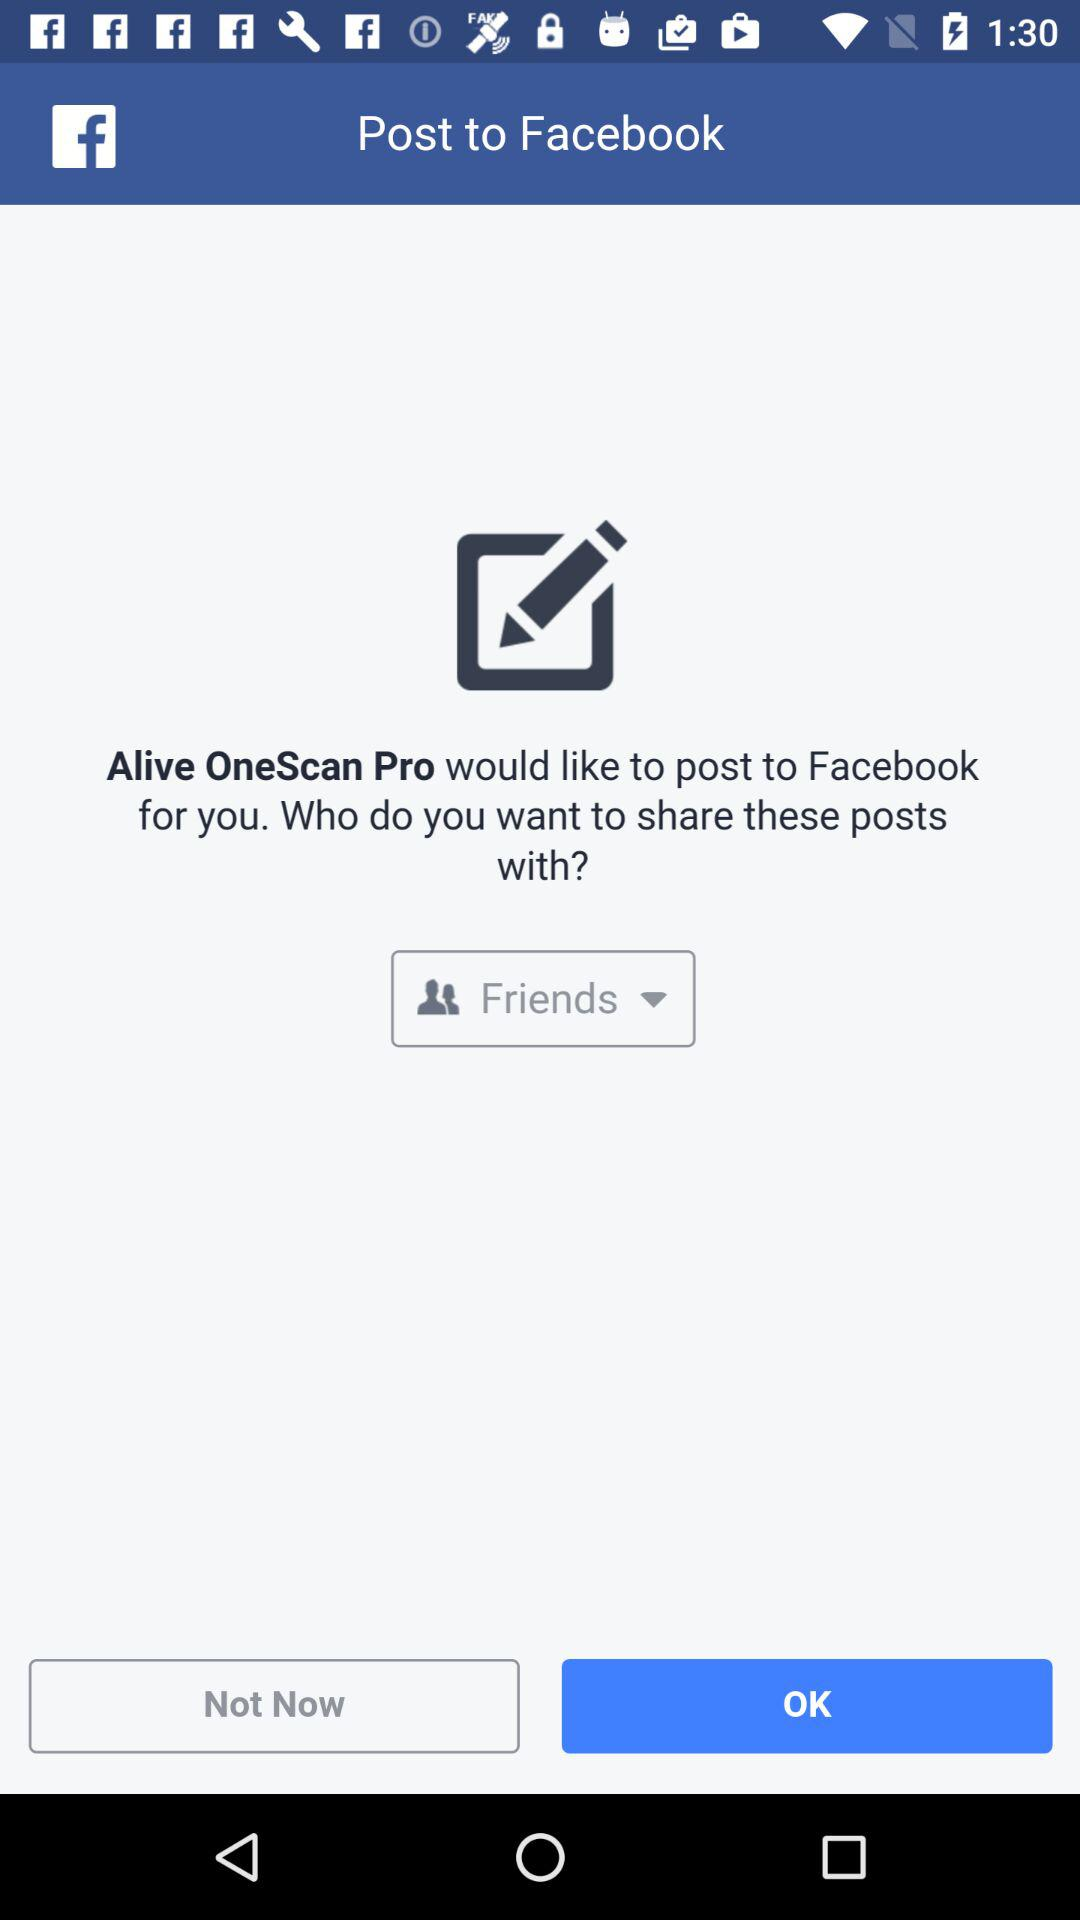With whom are the posts shared? The posts are shared with "Friends". 